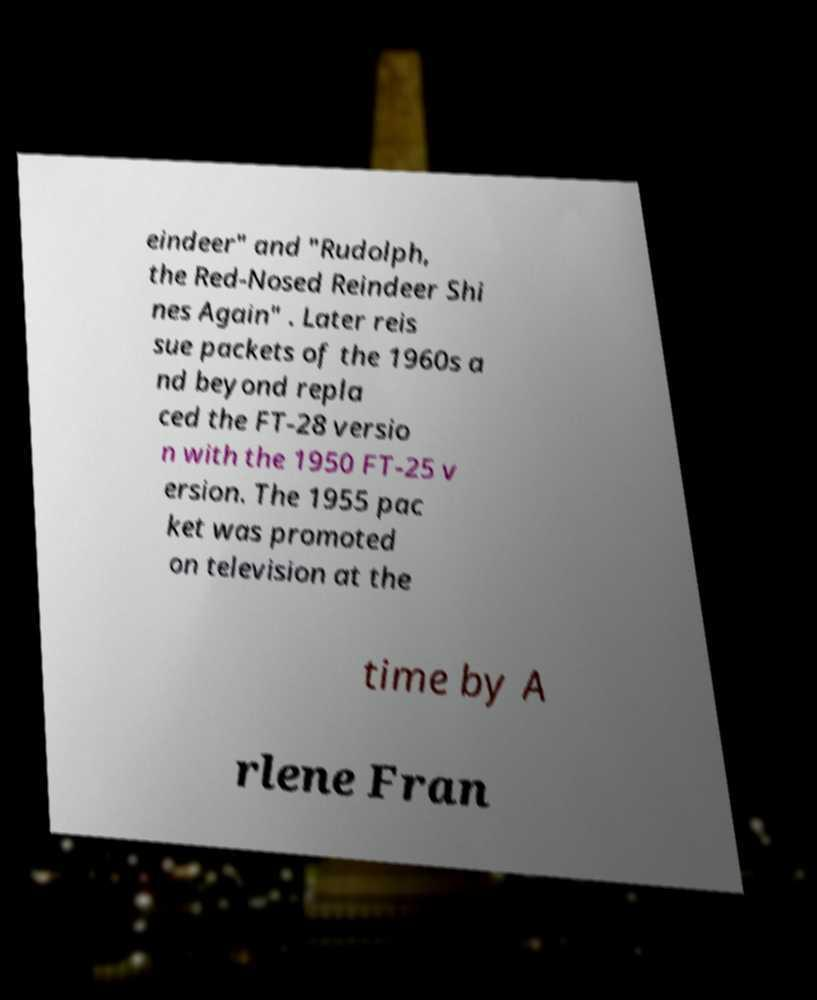Could you assist in decoding the text presented in this image and type it out clearly? eindeer" and "Rudolph, the Red-Nosed Reindeer Shi nes Again" . Later reis sue packets of the 1960s a nd beyond repla ced the FT-28 versio n with the 1950 FT-25 v ersion. The 1955 pac ket was promoted on television at the time by A rlene Fran 